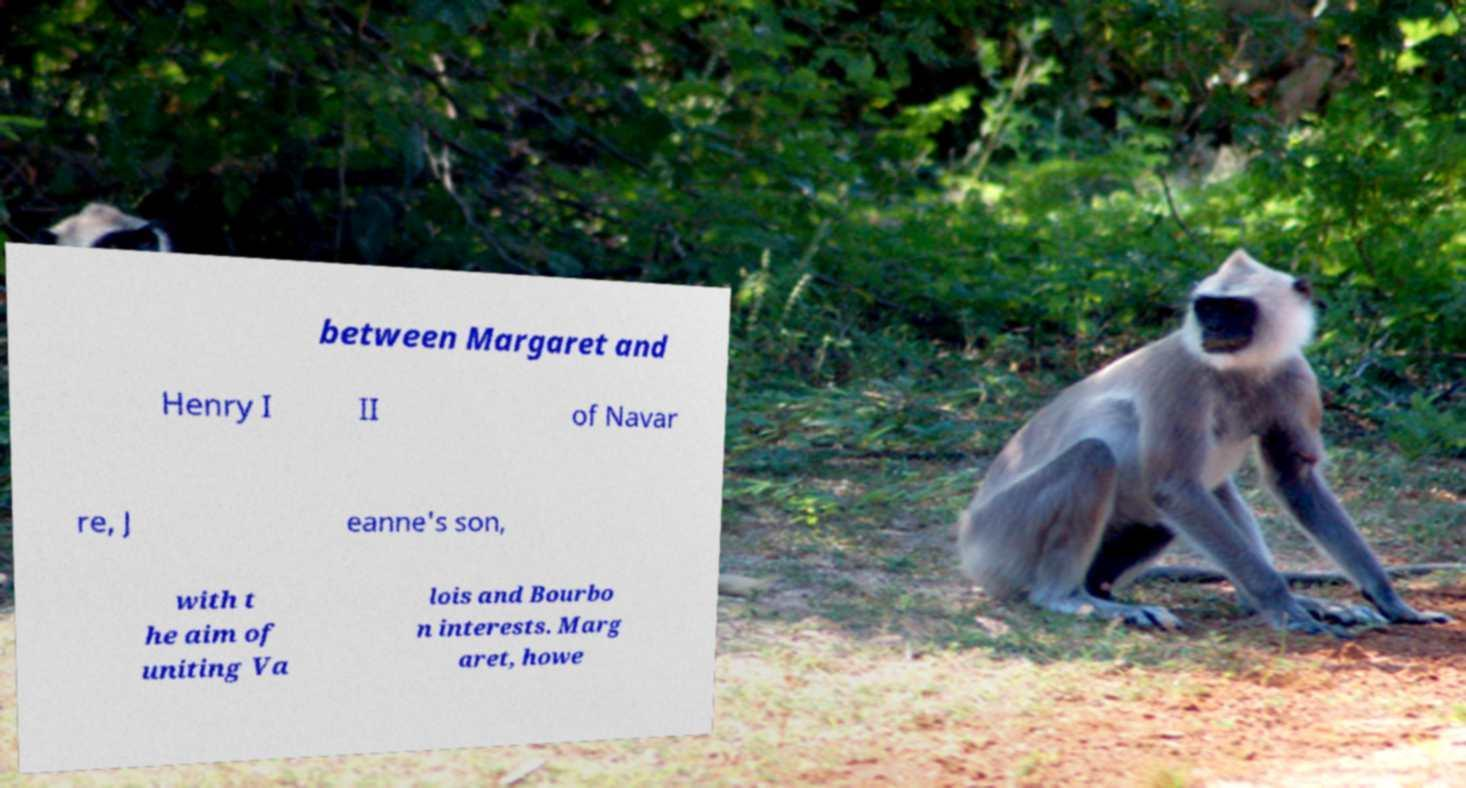There's text embedded in this image that I need extracted. Can you transcribe it verbatim? between Margaret and Henry I II of Navar re, J eanne's son, with t he aim of uniting Va lois and Bourbo n interests. Marg aret, howe 